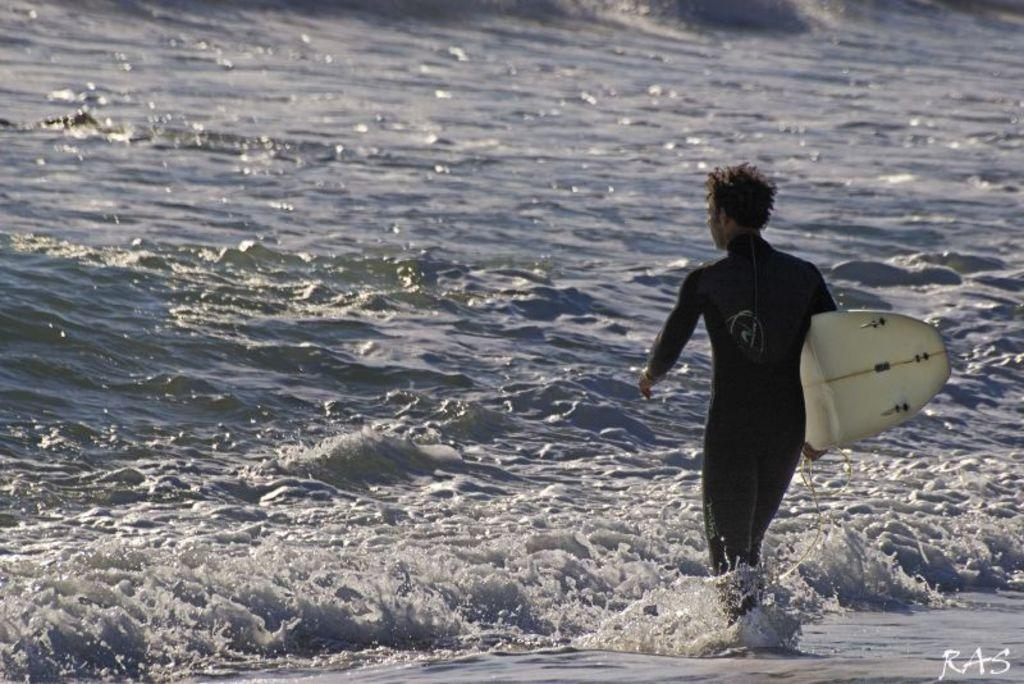What is the main subject of the image? There is a person in the image. What is the person wearing? The person is wearing a black dress. What is the person doing in the image? The person is standing. What object is the person holding? The person is holding a white surfboard. What can be seen in the background of the image? The sky is visible in the background of the image. How many chickens are visible in the image? There are no chickens present in the image. What type of trade is being conducted in the image? There is no trade being conducted in the image; it features a person holding a surfboard. 